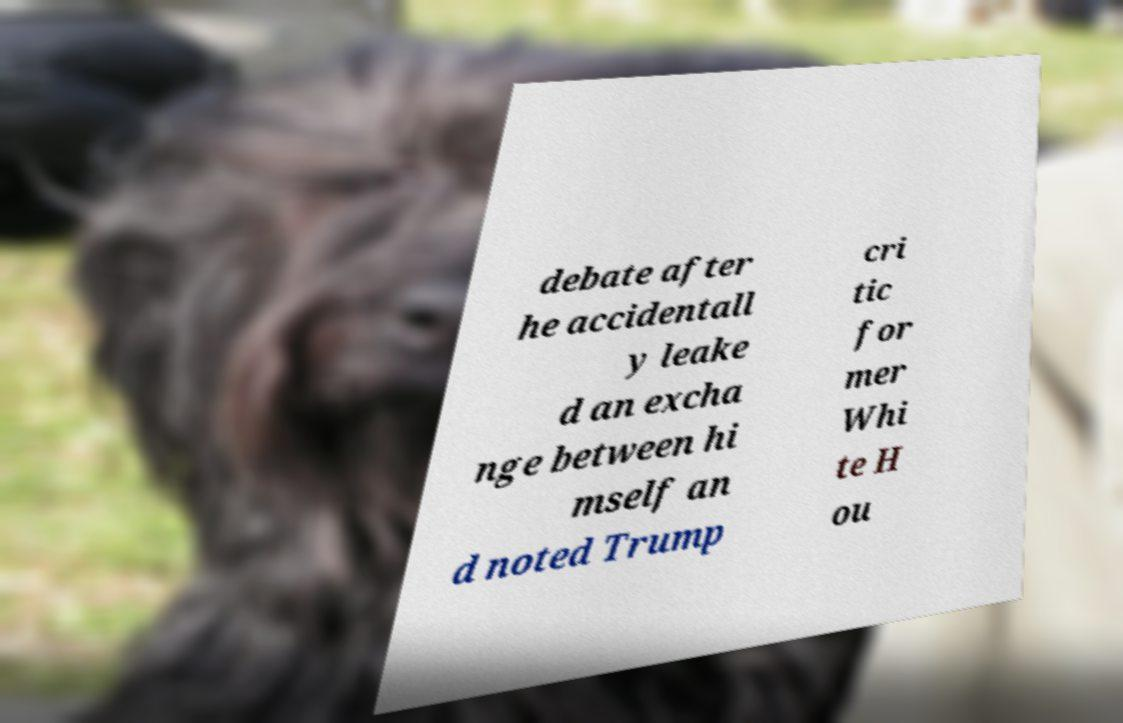Please identify and transcribe the text found in this image. debate after he accidentall y leake d an excha nge between hi mself an d noted Trump cri tic for mer Whi te H ou 